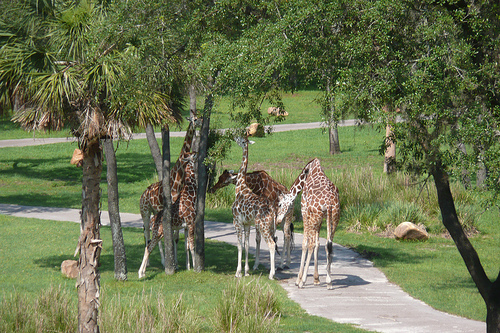How many giraffes? There are four giraffes in the image, evenly distributed across the scene which suggests a calm and serene setting, perfect for observing these magnificent creatures in their natural-like habitat. 